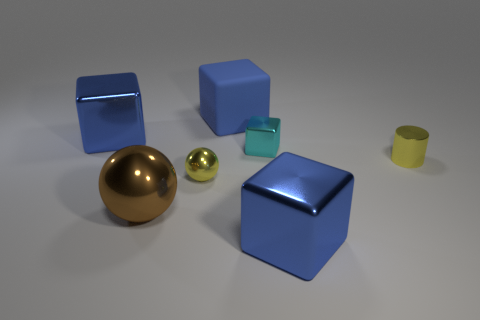How many blue blocks must be subtracted to get 1 blue blocks? 2 Subtract all blue spheres. How many blue blocks are left? 3 Add 3 small yellow cylinders. How many objects exist? 10 Subtract all blocks. How many objects are left? 3 Add 7 cyan shiny blocks. How many cyan shiny blocks are left? 8 Add 5 small green matte things. How many small green matte things exist? 5 Subtract 0 red cylinders. How many objects are left? 7 Subtract all large brown shiny objects. Subtract all tiny cubes. How many objects are left? 5 